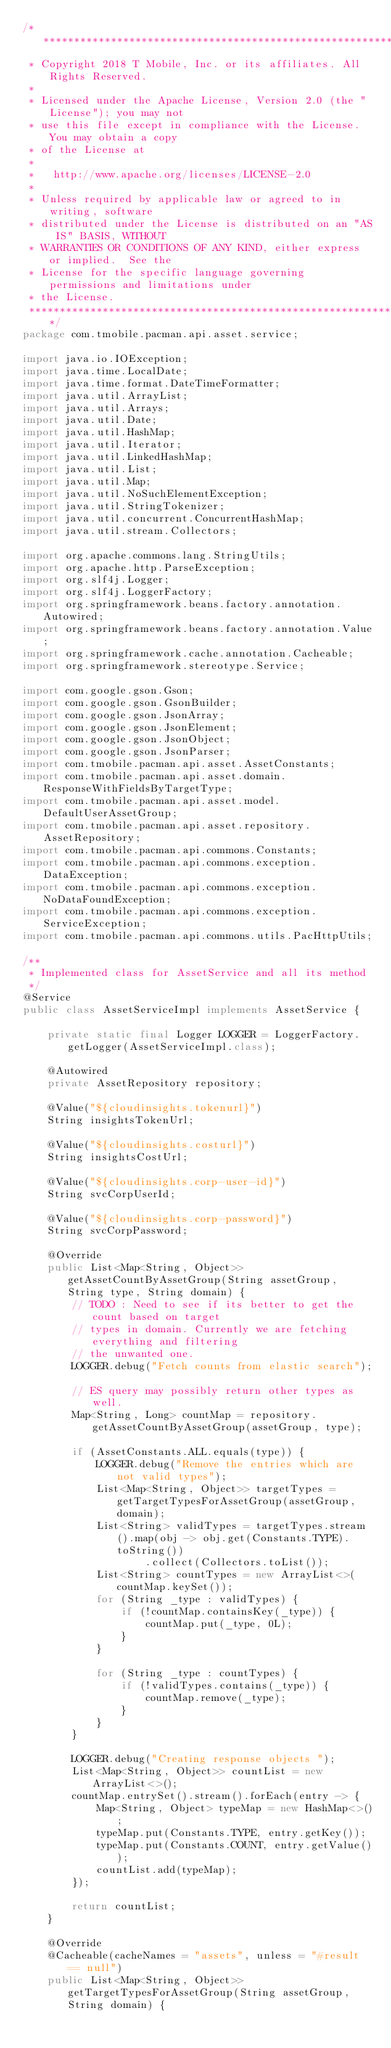Convert code to text. <code><loc_0><loc_0><loc_500><loc_500><_Java_>/*******************************************************************************
 * Copyright 2018 T Mobile, Inc. or its affiliates. All Rights Reserved.
 * 
 * Licensed under the Apache License, Version 2.0 (the "License"); you may not
 * use this file except in compliance with the License.  You may obtain a copy
 * of the License at
 * 
 *   http://www.apache.org/licenses/LICENSE-2.0
 * 
 * Unless required by applicable law or agreed to in writing, software
 * distributed under the License is distributed on an "AS IS" BASIS, WITHOUT
 * WARRANTIES OR CONDITIONS OF ANY KIND, either express or implied.  See the
 * License for the specific language governing permissions and limitations under
 * the License.
 ******************************************************************************/
package com.tmobile.pacman.api.asset.service;

import java.io.IOException;
import java.time.LocalDate;
import java.time.format.DateTimeFormatter;
import java.util.ArrayList;
import java.util.Arrays;
import java.util.Date;
import java.util.HashMap;
import java.util.Iterator;
import java.util.LinkedHashMap;
import java.util.List;
import java.util.Map;
import java.util.NoSuchElementException;
import java.util.StringTokenizer;
import java.util.concurrent.ConcurrentHashMap;
import java.util.stream.Collectors;

import org.apache.commons.lang.StringUtils;
import org.apache.http.ParseException;
import org.slf4j.Logger;
import org.slf4j.LoggerFactory;
import org.springframework.beans.factory.annotation.Autowired;
import org.springframework.beans.factory.annotation.Value;
import org.springframework.cache.annotation.Cacheable;
import org.springframework.stereotype.Service;

import com.google.gson.Gson;
import com.google.gson.GsonBuilder;
import com.google.gson.JsonArray;
import com.google.gson.JsonElement;
import com.google.gson.JsonObject;
import com.google.gson.JsonParser;
import com.tmobile.pacman.api.asset.AssetConstants;
import com.tmobile.pacman.api.asset.domain.ResponseWithFieldsByTargetType;
import com.tmobile.pacman.api.asset.model.DefaultUserAssetGroup;
import com.tmobile.pacman.api.asset.repository.AssetRepository;
import com.tmobile.pacman.api.commons.Constants;
import com.tmobile.pacman.api.commons.exception.DataException;
import com.tmobile.pacman.api.commons.exception.NoDataFoundException;
import com.tmobile.pacman.api.commons.exception.ServiceException;
import com.tmobile.pacman.api.commons.utils.PacHttpUtils;

/**
 * Implemented class for AssetService and all its method
 */
@Service
public class AssetServiceImpl implements AssetService {

    private static final Logger LOGGER = LoggerFactory.getLogger(AssetServiceImpl.class);

    @Autowired
    private AssetRepository repository;
    
    @Value("${cloudinsights.tokenurl}")
    String insightsTokenUrl;

    @Value("${cloudinsights.costurl}")
    String insightsCostUrl;

    @Value("${cloudinsights.corp-user-id}")
    String svcCorpUserId;

    @Value("${cloudinsights.corp-password}")
    String svcCorpPassword;

    @Override
    public List<Map<String, Object>> getAssetCountByAssetGroup(String assetGroup, String type, String domain) {
        // TODO : Need to see if its better to get the count based on target
        // types in domain. Currently we are fetching everything and filtering
        // the unwanted one.
        LOGGER.debug("Fetch counts from elastic search");

        // ES query may possibly return other types as well.
        Map<String, Long> countMap = repository.getAssetCountByAssetGroup(assetGroup, type);

        if (AssetConstants.ALL.equals(type)) {
            LOGGER.debug("Remove the entries which are not valid types");
            List<Map<String, Object>> targetTypes = getTargetTypesForAssetGroup(assetGroup, domain);
            List<String> validTypes = targetTypes.stream().map(obj -> obj.get(Constants.TYPE).toString())
                    .collect(Collectors.toList());
            List<String> countTypes = new ArrayList<>(countMap.keySet());
            for (String _type : validTypes) {
                if (!countMap.containsKey(_type)) {
                    countMap.put(_type, 0L);
                }
            }

            for (String _type : countTypes) {
                if (!validTypes.contains(_type)) {
                    countMap.remove(_type);
                }
            }
        }

        LOGGER.debug("Creating response objects ");
        List<Map<String, Object>> countList = new ArrayList<>();
        countMap.entrySet().stream().forEach(entry -> {
            Map<String, Object> typeMap = new HashMap<>();
            typeMap.put(Constants.TYPE, entry.getKey());
            typeMap.put(Constants.COUNT, entry.getValue());
            countList.add(typeMap);
        });

        return countList;
    }

    @Override
    @Cacheable(cacheNames = "assets", unless = "#result == null")
    public List<Map<String, Object>> getTargetTypesForAssetGroup(String assetGroup, String domain) {</code> 